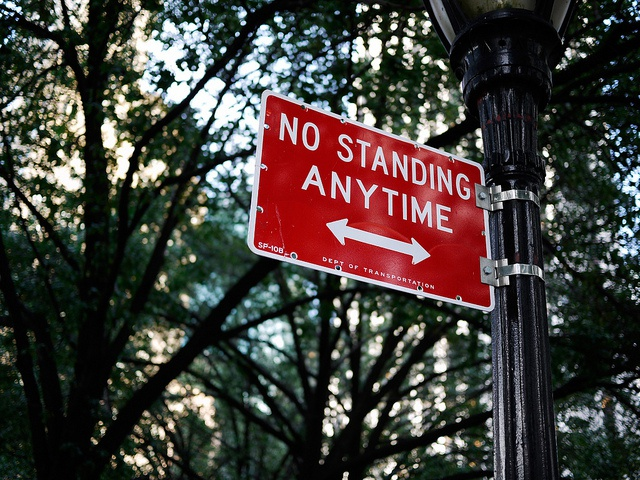Describe the objects in this image and their specific colors. I can see various objects in this image with different colors. 